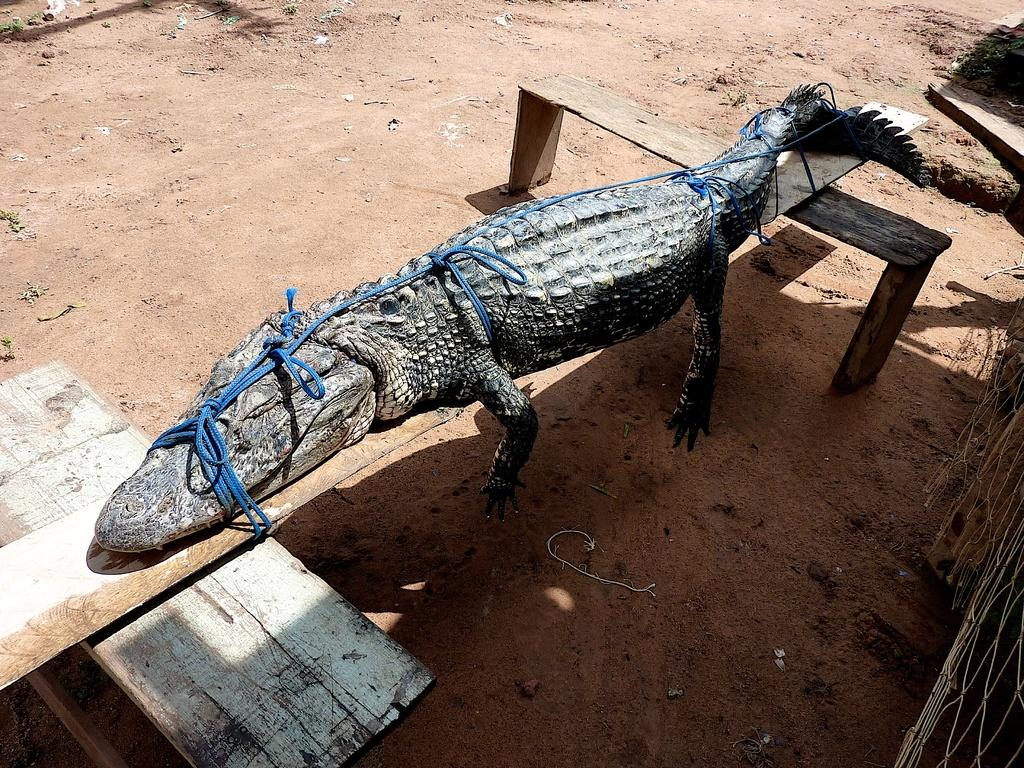What animal is in the image? There is a crocodile in the image. Where is the crocodile located? The crocodile is on a bench. When was the image taken? The image was taken during the day. On what surface was the image taken? The image is taken on the ground. What type of kettle is visible in the image? There is no kettle present in the image. What angle is the crocodile sitting at on the bench? The angle at which the crocodile is sitting on the bench cannot be determined from the image. 